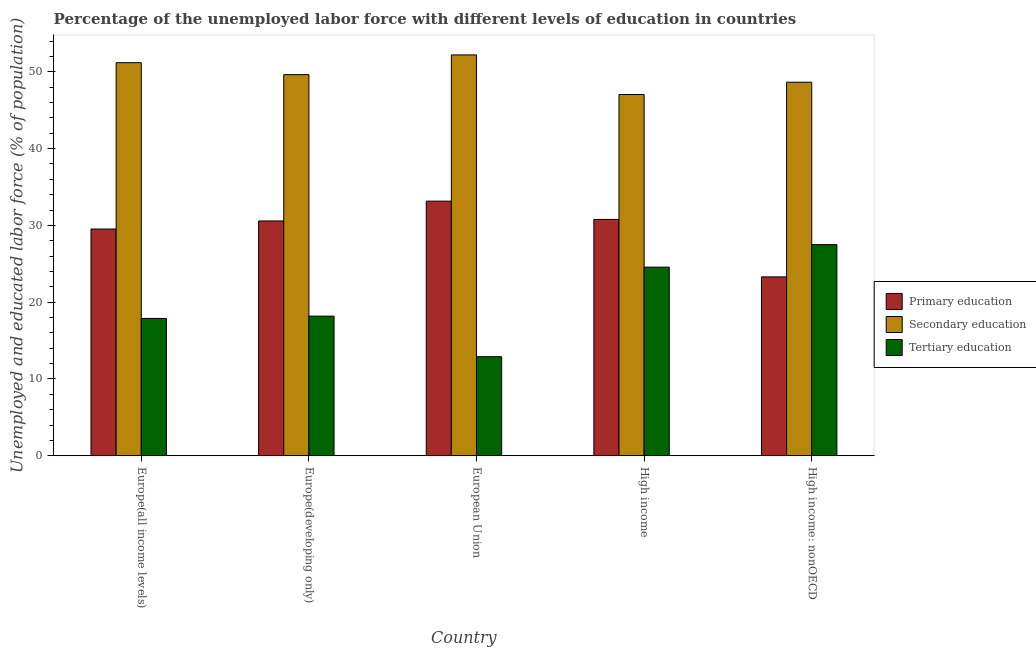How many different coloured bars are there?
Offer a terse response. 3. Are the number of bars on each tick of the X-axis equal?
Offer a terse response. Yes. What is the label of the 1st group of bars from the left?
Offer a terse response. Europe(all income levels). What is the percentage of labor force who received secondary education in European Union?
Offer a very short reply. 52.2. Across all countries, what is the maximum percentage of labor force who received primary education?
Provide a short and direct response. 33.15. Across all countries, what is the minimum percentage of labor force who received primary education?
Provide a short and direct response. 23.29. What is the total percentage of labor force who received tertiary education in the graph?
Your answer should be very brief. 101.01. What is the difference between the percentage of labor force who received primary education in Europe(all income levels) and that in Europe(developing only)?
Your answer should be very brief. -1.05. What is the difference between the percentage of labor force who received secondary education in European Union and the percentage of labor force who received tertiary education in Europe(developing only)?
Your answer should be compact. 34.02. What is the average percentage of labor force who received primary education per country?
Give a very brief answer. 29.46. What is the difference between the percentage of labor force who received secondary education and percentage of labor force who received primary education in Europe(developing only)?
Your answer should be compact. 19.05. What is the ratio of the percentage of labor force who received primary education in Europe(developing only) to that in High income: nonOECD?
Provide a short and direct response. 1.31. Is the percentage of labor force who received primary education in European Union less than that in High income: nonOECD?
Provide a short and direct response. No. Is the difference between the percentage of labor force who received tertiary education in Europe(all income levels) and Europe(developing only) greater than the difference between the percentage of labor force who received secondary education in Europe(all income levels) and Europe(developing only)?
Give a very brief answer. No. What is the difference between the highest and the second highest percentage of labor force who received tertiary education?
Provide a succinct answer. 2.93. What is the difference between the highest and the lowest percentage of labor force who received secondary education?
Give a very brief answer. 5.15. Is the sum of the percentage of labor force who received tertiary education in Europe(all income levels) and High income greater than the maximum percentage of labor force who received secondary education across all countries?
Offer a terse response. No. What does the 3rd bar from the left in Europe(all income levels) represents?
Make the answer very short. Tertiary education. How many countries are there in the graph?
Offer a very short reply. 5. What is the difference between two consecutive major ticks on the Y-axis?
Provide a short and direct response. 10. Are the values on the major ticks of Y-axis written in scientific E-notation?
Keep it short and to the point. No. Does the graph contain any zero values?
Provide a short and direct response. No. Where does the legend appear in the graph?
Ensure brevity in your answer.  Center right. How many legend labels are there?
Make the answer very short. 3. How are the legend labels stacked?
Your answer should be very brief. Vertical. What is the title of the graph?
Ensure brevity in your answer.  Percentage of the unemployed labor force with different levels of education in countries. Does "Transport equipments" appear as one of the legend labels in the graph?
Your answer should be very brief. No. What is the label or title of the Y-axis?
Your answer should be very brief. Unemployed and educated labor force (% of population). What is the Unemployed and educated labor force (% of population) in Primary education in Europe(all income levels)?
Your response must be concise. 29.52. What is the Unemployed and educated labor force (% of population) of Secondary education in Europe(all income levels)?
Give a very brief answer. 51.19. What is the Unemployed and educated labor force (% of population) in Tertiary education in Europe(all income levels)?
Your answer should be compact. 17.88. What is the Unemployed and educated labor force (% of population) in Primary education in Europe(developing only)?
Offer a very short reply. 30.58. What is the Unemployed and educated labor force (% of population) of Secondary education in Europe(developing only)?
Your response must be concise. 49.63. What is the Unemployed and educated labor force (% of population) in Tertiary education in Europe(developing only)?
Give a very brief answer. 18.18. What is the Unemployed and educated labor force (% of population) of Primary education in European Union?
Provide a short and direct response. 33.15. What is the Unemployed and educated labor force (% of population) of Secondary education in European Union?
Keep it short and to the point. 52.2. What is the Unemployed and educated labor force (% of population) of Tertiary education in European Union?
Ensure brevity in your answer.  12.9. What is the Unemployed and educated labor force (% of population) in Primary education in High income?
Your answer should be compact. 30.77. What is the Unemployed and educated labor force (% of population) of Secondary education in High income?
Ensure brevity in your answer.  47.05. What is the Unemployed and educated labor force (% of population) of Tertiary education in High income?
Offer a very short reply. 24.56. What is the Unemployed and educated labor force (% of population) in Primary education in High income: nonOECD?
Make the answer very short. 23.29. What is the Unemployed and educated labor force (% of population) in Secondary education in High income: nonOECD?
Provide a succinct answer. 48.64. What is the Unemployed and educated labor force (% of population) in Tertiary education in High income: nonOECD?
Make the answer very short. 27.49. Across all countries, what is the maximum Unemployed and educated labor force (% of population) of Primary education?
Provide a succinct answer. 33.15. Across all countries, what is the maximum Unemployed and educated labor force (% of population) of Secondary education?
Give a very brief answer. 52.2. Across all countries, what is the maximum Unemployed and educated labor force (% of population) in Tertiary education?
Ensure brevity in your answer.  27.49. Across all countries, what is the minimum Unemployed and educated labor force (% of population) in Primary education?
Your answer should be compact. 23.29. Across all countries, what is the minimum Unemployed and educated labor force (% of population) in Secondary education?
Provide a succinct answer. 47.05. Across all countries, what is the minimum Unemployed and educated labor force (% of population) of Tertiary education?
Give a very brief answer. 12.9. What is the total Unemployed and educated labor force (% of population) in Primary education in the graph?
Keep it short and to the point. 147.32. What is the total Unemployed and educated labor force (% of population) of Secondary education in the graph?
Your response must be concise. 248.7. What is the total Unemployed and educated labor force (% of population) in Tertiary education in the graph?
Your answer should be compact. 101.01. What is the difference between the Unemployed and educated labor force (% of population) of Primary education in Europe(all income levels) and that in Europe(developing only)?
Your answer should be compact. -1.05. What is the difference between the Unemployed and educated labor force (% of population) of Secondary education in Europe(all income levels) and that in Europe(developing only)?
Offer a very short reply. 1.56. What is the difference between the Unemployed and educated labor force (% of population) in Tertiary education in Europe(all income levels) and that in Europe(developing only)?
Keep it short and to the point. -0.3. What is the difference between the Unemployed and educated labor force (% of population) in Primary education in Europe(all income levels) and that in European Union?
Ensure brevity in your answer.  -3.63. What is the difference between the Unemployed and educated labor force (% of population) of Secondary education in Europe(all income levels) and that in European Union?
Provide a succinct answer. -1.01. What is the difference between the Unemployed and educated labor force (% of population) in Tertiary education in Europe(all income levels) and that in European Union?
Give a very brief answer. 4.98. What is the difference between the Unemployed and educated labor force (% of population) in Primary education in Europe(all income levels) and that in High income?
Your response must be concise. -1.25. What is the difference between the Unemployed and educated labor force (% of population) in Secondary education in Europe(all income levels) and that in High income?
Give a very brief answer. 4.14. What is the difference between the Unemployed and educated labor force (% of population) in Tertiary education in Europe(all income levels) and that in High income?
Make the answer very short. -6.68. What is the difference between the Unemployed and educated labor force (% of population) in Primary education in Europe(all income levels) and that in High income: nonOECD?
Keep it short and to the point. 6.23. What is the difference between the Unemployed and educated labor force (% of population) in Secondary education in Europe(all income levels) and that in High income: nonOECD?
Offer a very short reply. 2.54. What is the difference between the Unemployed and educated labor force (% of population) in Tertiary education in Europe(all income levels) and that in High income: nonOECD?
Your answer should be compact. -9.61. What is the difference between the Unemployed and educated labor force (% of population) of Primary education in Europe(developing only) and that in European Union?
Your answer should be compact. -2.58. What is the difference between the Unemployed and educated labor force (% of population) of Secondary education in Europe(developing only) and that in European Union?
Give a very brief answer. -2.57. What is the difference between the Unemployed and educated labor force (% of population) in Tertiary education in Europe(developing only) and that in European Union?
Offer a terse response. 5.28. What is the difference between the Unemployed and educated labor force (% of population) of Primary education in Europe(developing only) and that in High income?
Provide a succinct answer. -0.2. What is the difference between the Unemployed and educated labor force (% of population) in Secondary education in Europe(developing only) and that in High income?
Offer a very short reply. 2.58. What is the difference between the Unemployed and educated labor force (% of population) in Tertiary education in Europe(developing only) and that in High income?
Provide a short and direct response. -6.38. What is the difference between the Unemployed and educated labor force (% of population) in Primary education in Europe(developing only) and that in High income: nonOECD?
Offer a very short reply. 7.29. What is the difference between the Unemployed and educated labor force (% of population) in Tertiary education in Europe(developing only) and that in High income: nonOECD?
Provide a short and direct response. -9.31. What is the difference between the Unemployed and educated labor force (% of population) of Primary education in European Union and that in High income?
Your answer should be compact. 2.38. What is the difference between the Unemployed and educated labor force (% of population) in Secondary education in European Union and that in High income?
Your answer should be compact. 5.15. What is the difference between the Unemployed and educated labor force (% of population) in Tertiary education in European Union and that in High income?
Your answer should be very brief. -11.66. What is the difference between the Unemployed and educated labor force (% of population) of Primary education in European Union and that in High income: nonOECD?
Provide a short and direct response. 9.86. What is the difference between the Unemployed and educated labor force (% of population) of Secondary education in European Union and that in High income: nonOECD?
Provide a short and direct response. 3.56. What is the difference between the Unemployed and educated labor force (% of population) of Tertiary education in European Union and that in High income: nonOECD?
Provide a short and direct response. -14.59. What is the difference between the Unemployed and educated labor force (% of population) in Primary education in High income and that in High income: nonOECD?
Ensure brevity in your answer.  7.48. What is the difference between the Unemployed and educated labor force (% of population) in Secondary education in High income and that in High income: nonOECD?
Offer a very short reply. -1.6. What is the difference between the Unemployed and educated labor force (% of population) of Tertiary education in High income and that in High income: nonOECD?
Make the answer very short. -2.93. What is the difference between the Unemployed and educated labor force (% of population) of Primary education in Europe(all income levels) and the Unemployed and educated labor force (% of population) of Secondary education in Europe(developing only)?
Offer a very short reply. -20.1. What is the difference between the Unemployed and educated labor force (% of population) in Primary education in Europe(all income levels) and the Unemployed and educated labor force (% of population) in Tertiary education in Europe(developing only)?
Offer a terse response. 11.34. What is the difference between the Unemployed and educated labor force (% of population) of Secondary education in Europe(all income levels) and the Unemployed and educated labor force (% of population) of Tertiary education in Europe(developing only)?
Offer a very short reply. 33.01. What is the difference between the Unemployed and educated labor force (% of population) in Primary education in Europe(all income levels) and the Unemployed and educated labor force (% of population) in Secondary education in European Union?
Make the answer very short. -22.67. What is the difference between the Unemployed and educated labor force (% of population) in Primary education in Europe(all income levels) and the Unemployed and educated labor force (% of population) in Tertiary education in European Union?
Your response must be concise. 16.63. What is the difference between the Unemployed and educated labor force (% of population) of Secondary education in Europe(all income levels) and the Unemployed and educated labor force (% of population) of Tertiary education in European Union?
Make the answer very short. 38.29. What is the difference between the Unemployed and educated labor force (% of population) in Primary education in Europe(all income levels) and the Unemployed and educated labor force (% of population) in Secondary education in High income?
Offer a terse response. -17.52. What is the difference between the Unemployed and educated labor force (% of population) in Primary education in Europe(all income levels) and the Unemployed and educated labor force (% of population) in Tertiary education in High income?
Give a very brief answer. 4.96. What is the difference between the Unemployed and educated labor force (% of population) of Secondary education in Europe(all income levels) and the Unemployed and educated labor force (% of population) of Tertiary education in High income?
Your answer should be compact. 26.63. What is the difference between the Unemployed and educated labor force (% of population) in Primary education in Europe(all income levels) and the Unemployed and educated labor force (% of population) in Secondary education in High income: nonOECD?
Keep it short and to the point. -19.12. What is the difference between the Unemployed and educated labor force (% of population) in Primary education in Europe(all income levels) and the Unemployed and educated labor force (% of population) in Tertiary education in High income: nonOECD?
Offer a very short reply. 2.03. What is the difference between the Unemployed and educated labor force (% of population) of Secondary education in Europe(all income levels) and the Unemployed and educated labor force (% of population) of Tertiary education in High income: nonOECD?
Ensure brevity in your answer.  23.7. What is the difference between the Unemployed and educated labor force (% of population) of Primary education in Europe(developing only) and the Unemployed and educated labor force (% of population) of Secondary education in European Union?
Offer a very short reply. -21.62. What is the difference between the Unemployed and educated labor force (% of population) in Primary education in Europe(developing only) and the Unemployed and educated labor force (% of population) in Tertiary education in European Union?
Provide a succinct answer. 17.68. What is the difference between the Unemployed and educated labor force (% of population) of Secondary education in Europe(developing only) and the Unemployed and educated labor force (% of population) of Tertiary education in European Union?
Offer a very short reply. 36.73. What is the difference between the Unemployed and educated labor force (% of population) of Primary education in Europe(developing only) and the Unemployed and educated labor force (% of population) of Secondary education in High income?
Your answer should be compact. -16.47. What is the difference between the Unemployed and educated labor force (% of population) of Primary education in Europe(developing only) and the Unemployed and educated labor force (% of population) of Tertiary education in High income?
Offer a terse response. 6.02. What is the difference between the Unemployed and educated labor force (% of population) in Secondary education in Europe(developing only) and the Unemployed and educated labor force (% of population) in Tertiary education in High income?
Offer a very short reply. 25.07. What is the difference between the Unemployed and educated labor force (% of population) of Primary education in Europe(developing only) and the Unemployed and educated labor force (% of population) of Secondary education in High income: nonOECD?
Your response must be concise. -18.07. What is the difference between the Unemployed and educated labor force (% of population) of Primary education in Europe(developing only) and the Unemployed and educated labor force (% of population) of Tertiary education in High income: nonOECD?
Your response must be concise. 3.09. What is the difference between the Unemployed and educated labor force (% of population) of Secondary education in Europe(developing only) and the Unemployed and educated labor force (% of population) of Tertiary education in High income: nonOECD?
Offer a very short reply. 22.14. What is the difference between the Unemployed and educated labor force (% of population) of Primary education in European Union and the Unemployed and educated labor force (% of population) of Secondary education in High income?
Your response must be concise. -13.89. What is the difference between the Unemployed and educated labor force (% of population) of Primary education in European Union and the Unemployed and educated labor force (% of population) of Tertiary education in High income?
Make the answer very short. 8.59. What is the difference between the Unemployed and educated labor force (% of population) in Secondary education in European Union and the Unemployed and educated labor force (% of population) in Tertiary education in High income?
Provide a succinct answer. 27.64. What is the difference between the Unemployed and educated labor force (% of population) of Primary education in European Union and the Unemployed and educated labor force (% of population) of Secondary education in High income: nonOECD?
Your answer should be very brief. -15.49. What is the difference between the Unemployed and educated labor force (% of population) of Primary education in European Union and the Unemployed and educated labor force (% of population) of Tertiary education in High income: nonOECD?
Keep it short and to the point. 5.66. What is the difference between the Unemployed and educated labor force (% of population) of Secondary education in European Union and the Unemployed and educated labor force (% of population) of Tertiary education in High income: nonOECD?
Provide a short and direct response. 24.71. What is the difference between the Unemployed and educated labor force (% of population) of Primary education in High income and the Unemployed and educated labor force (% of population) of Secondary education in High income: nonOECD?
Give a very brief answer. -17.87. What is the difference between the Unemployed and educated labor force (% of population) of Primary education in High income and the Unemployed and educated labor force (% of population) of Tertiary education in High income: nonOECD?
Make the answer very short. 3.28. What is the difference between the Unemployed and educated labor force (% of population) in Secondary education in High income and the Unemployed and educated labor force (% of population) in Tertiary education in High income: nonOECD?
Your answer should be very brief. 19.56. What is the average Unemployed and educated labor force (% of population) of Primary education per country?
Provide a succinct answer. 29.46. What is the average Unemployed and educated labor force (% of population) of Secondary education per country?
Your answer should be very brief. 49.74. What is the average Unemployed and educated labor force (% of population) of Tertiary education per country?
Make the answer very short. 20.2. What is the difference between the Unemployed and educated labor force (% of population) of Primary education and Unemployed and educated labor force (% of population) of Secondary education in Europe(all income levels)?
Your response must be concise. -21.66. What is the difference between the Unemployed and educated labor force (% of population) of Primary education and Unemployed and educated labor force (% of population) of Tertiary education in Europe(all income levels)?
Keep it short and to the point. 11.64. What is the difference between the Unemployed and educated labor force (% of population) in Secondary education and Unemployed and educated labor force (% of population) in Tertiary education in Europe(all income levels)?
Make the answer very short. 33.31. What is the difference between the Unemployed and educated labor force (% of population) in Primary education and Unemployed and educated labor force (% of population) in Secondary education in Europe(developing only)?
Your answer should be very brief. -19.05. What is the difference between the Unemployed and educated labor force (% of population) of Primary education and Unemployed and educated labor force (% of population) of Tertiary education in Europe(developing only)?
Keep it short and to the point. 12.4. What is the difference between the Unemployed and educated labor force (% of population) in Secondary education and Unemployed and educated labor force (% of population) in Tertiary education in Europe(developing only)?
Offer a terse response. 31.45. What is the difference between the Unemployed and educated labor force (% of population) in Primary education and Unemployed and educated labor force (% of population) in Secondary education in European Union?
Provide a succinct answer. -19.04. What is the difference between the Unemployed and educated labor force (% of population) of Primary education and Unemployed and educated labor force (% of population) of Tertiary education in European Union?
Your response must be concise. 20.26. What is the difference between the Unemployed and educated labor force (% of population) in Secondary education and Unemployed and educated labor force (% of population) in Tertiary education in European Union?
Give a very brief answer. 39.3. What is the difference between the Unemployed and educated labor force (% of population) in Primary education and Unemployed and educated labor force (% of population) in Secondary education in High income?
Keep it short and to the point. -16.27. What is the difference between the Unemployed and educated labor force (% of population) in Primary education and Unemployed and educated labor force (% of population) in Tertiary education in High income?
Provide a short and direct response. 6.21. What is the difference between the Unemployed and educated labor force (% of population) in Secondary education and Unemployed and educated labor force (% of population) in Tertiary education in High income?
Your answer should be compact. 22.49. What is the difference between the Unemployed and educated labor force (% of population) of Primary education and Unemployed and educated labor force (% of population) of Secondary education in High income: nonOECD?
Keep it short and to the point. -25.35. What is the difference between the Unemployed and educated labor force (% of population) in Primary education and Unemployed and educated labor force (% of population) in Tertiary education in High income: nonOECD?
Your answer should be very brief. -4.2. What is the difference between the Unemployed and educated labor force (% of population) of Secondary education and Unemployed and educated labor force (% of population) of Tertiary education in High income: nonOECD?
Keep it short and to the point. 21.15. What is the ratio of the Unemployed and educated labor force (% of population) in Primary education in Europe(all income levels) to that in Europe(developing only)?
Your answer should be compact. 0.97. What is the ratio of the Unemployed and educated labor force (% of population) in Secondary education in Europe(all income levels) to that in Europe(developing only)?
Your answer should be compact. 1.03. What is the ratio of the Unemployed and educated labor force (% of population) of Tertiary education in Europe(all income levels) to that in Europe(developing only)?
Your answer should be very brief. 0.98. What is the ratio of the Unemployed and educated labor force (% of population) in Primary education in Europe(all income levels) to that in European Union?
Provide a succinct answer. 0.89. What is the ratio of the Unemployed and educated labor force (% of population) in Secondary education in Europe(all income levels) to that in European Union?
Keep it short and to the point. 0.98. What is the ratio of the Unemployed and educated labor force (% of population) of Tertiary education in Europe(all income levels) to that in European Union?
Your answer should be compact. 1.39. What is the ratio of the Unemployed and educated labor force (% of population) of Primary education in Europe(all income levels) to that in High income?
Ensure brevity in your answer.  0.96. What is the ratio of the Unemployed and educated labor force (% of population) in Secondary education in Europe(all income levels) to that in High income?
Provide a short and direct response. 1.09. What is the ratio of the Unemployed and educated labor force (% of population) of Tertiary education in Europe(all income levels) to that in High income?
Provide a short and direct response. 0.73. What is the ratio of the Unemployed and educated labor force (% of population) in Primary education in Europe(all income levels) to that in High income: nonOECD?
Offer a very short reply. 1.27. What is the ratio of the Unemployed and educated labor force (% of population) in Secondary education in Europe(all income levels) to that in High income: nonOECD?
Ensure brevity in your answer.  1.05. What is the ratio of the Unemployed and educated labor force (% of population) of Tertiary education in Europe(all income levels) to that in High income: nonOECD?
Provide a short and direct response. 0.65. What is the ratio of the Unemployed and educated labor force (% of population) in Primary education in Europe(developing only) to that in European Union?
Provide a short and direct response. 0.92. What is the ratio of the Unemployed and educated labor force (% of population) of Secondary education in Europe(developing only) to that in European Union?
Provide a short and direct response. 0.95. What is the ratio of the Unemployed and educated labor force (% of population) in Tertiary education in Europe(developing only) to that in European Union?
Make the answer very short. 1.41. What is the ratio of the Unemployed and educated labor force (% of population) of Secondary education in Europe(developing only) to that in High income?
Make the answer very short. 1.05. What is the ratio of the Unemployed and educated labor force (% of population) of Tertiary education in Europe(developing only) to that in High income?
Your response must be concise. 0.74. What is the ratio of the Unemployed and educated labor force (% of population) of Primary education in Europe(developing only) to that in High income: nonOECD?
Your response must be concise. 1.31. What is the ratio of the Unemployed and educated labor force (% of population) of Secondary education in Europe(developing only) to that in High income: nonOECD?
Provide a succinct answer. 1.02. What is the ratio of the Unemployed and educated labor force (% of population) in Tertiary education in Europe(developing only) to that in High income: nonOECD?
Your answer should be very brief. 0.66. What is the ratio of the Unemployed and educated labor force (% of population) in Primary education in European Union to that in High income?
Ensure brevity in your answer.  1.08. What is the ratio of the Unemployed and educated labor force (% of population) in Secondary education in European Union to that in High income?
Give a very brief answer. 1.11. What is the ratio of the Unemployed and educated labor force (% of population) in Tertiary education in European Union to that in High income?
Your answer should be very brief. 0.53. What is the ratio of the Unemployed and educated labor force (% of population) in Primary education in European Union to that in High income: nonOECD?
Your answer should be compact. 1.42. What is the ratio of the Unemployed and educated labor force (% of population) of Secondary education in European Union to that in High income: nonOECD?
Give a very brief answer. 1.07. What is the ratio of the Unemployed and educated labor force (% of population) of Tertiary education in European Union to that in High income: nonOECD?
Your response must be concise. 0.47. What is the ratio of the Unemployed and educated labor force (% of population) in Primary education in High income to that in High income: nonOECD?
Ensure brevity in your answer.  1.32. What is the ratio of the Unemployed and educated labor force (% of population) in Secondary education in High income to that in High income: nonOECD?
Make the answer very short. 0.97. What is the ratio of the Unemployed and educated labor force (% of population) of Tertiary education in High income to that in High income: nonOECD?
Provide a succinct answer. 0.89. What is the difference between the highest and the second highest Unemployed and educated labor force (% of population) in Primary education?
Make the answer very short. 2.38. What is the difference between the highest and the second highest Unemployed and educated labor force (% of population) of Secondary education?
Your answer should be very brief. 1.01. What is the difference between the highest and the second highest Unemployed and educated labor force (% of population) of Tertiary education?
Ensure brevity in your answer.  2.93. What is the difference between the highest and the lowest Unemployed and educated labor force (% of population) in Primary education?
Ensure brevity in your answer.  9.86. What is the difference between the highest and the lowest Unemployed and educated labor force (% of population) of Secondary education?
Make the answer very short. 5.15. What is the difference between the highest and the lowest Unemployed and educated labor force (% of population) of Tertiary education?
Your answer should be compact. 14.59. 